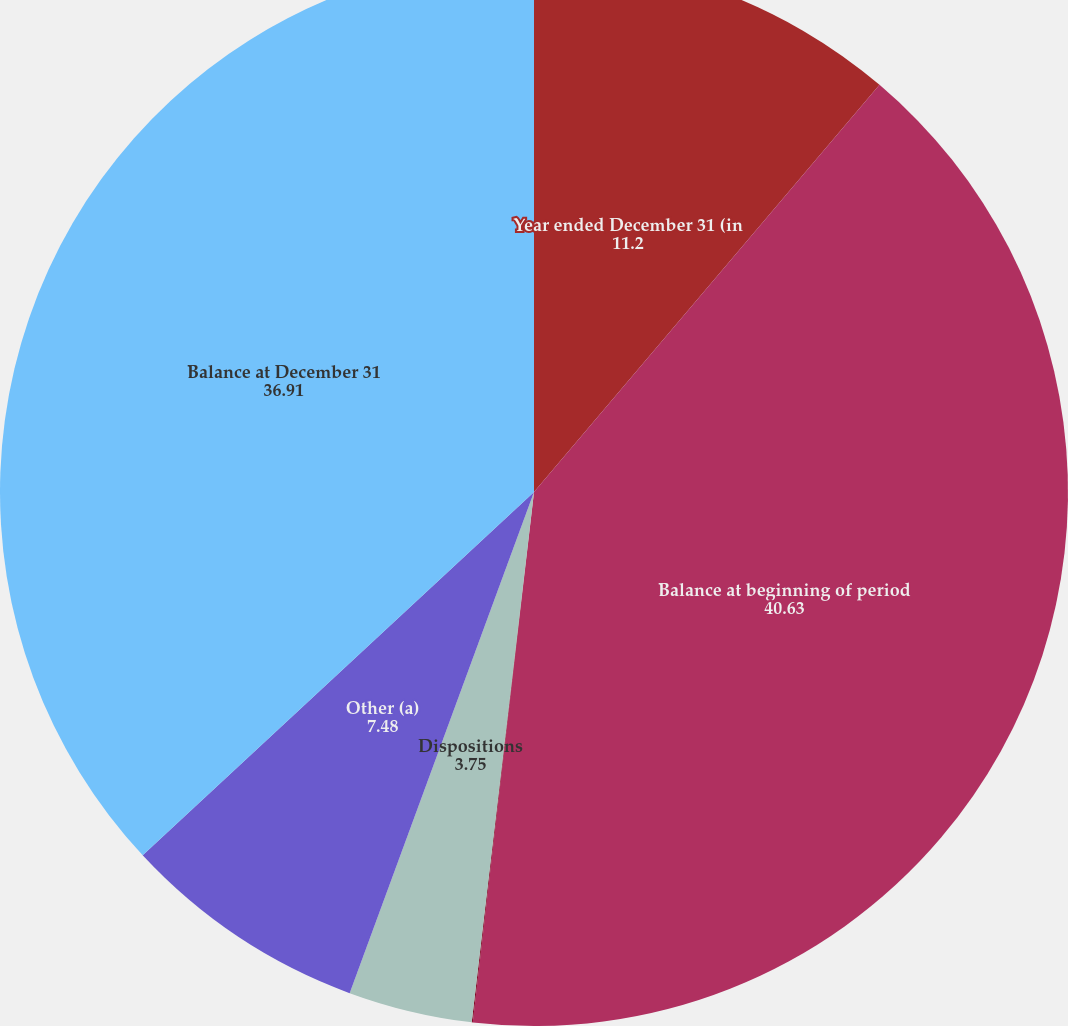Convert chart. <chart><loc_0><loc_0><loc_500><loc_500><pie_chart><fcel>Year ended December 31 (in<fcel>Balance at beginning of period<fcel>Business combinations<fcel>Dispositions<fcel>Other (a)<fcel>Balance at December 31<nl><fcel>11.2%<fcel>40.63%<fcel>0.03%<fcel>3.75%<fcel>7.48%<fcel>36.91%<nl></chart> 